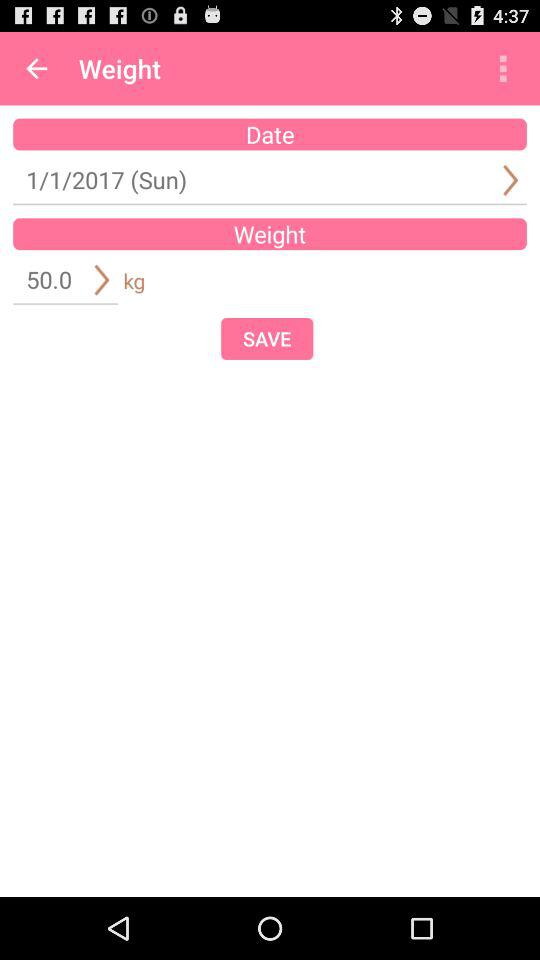What is the mentioned date? The mentioned date is Sunday, 1st January, 2017. 